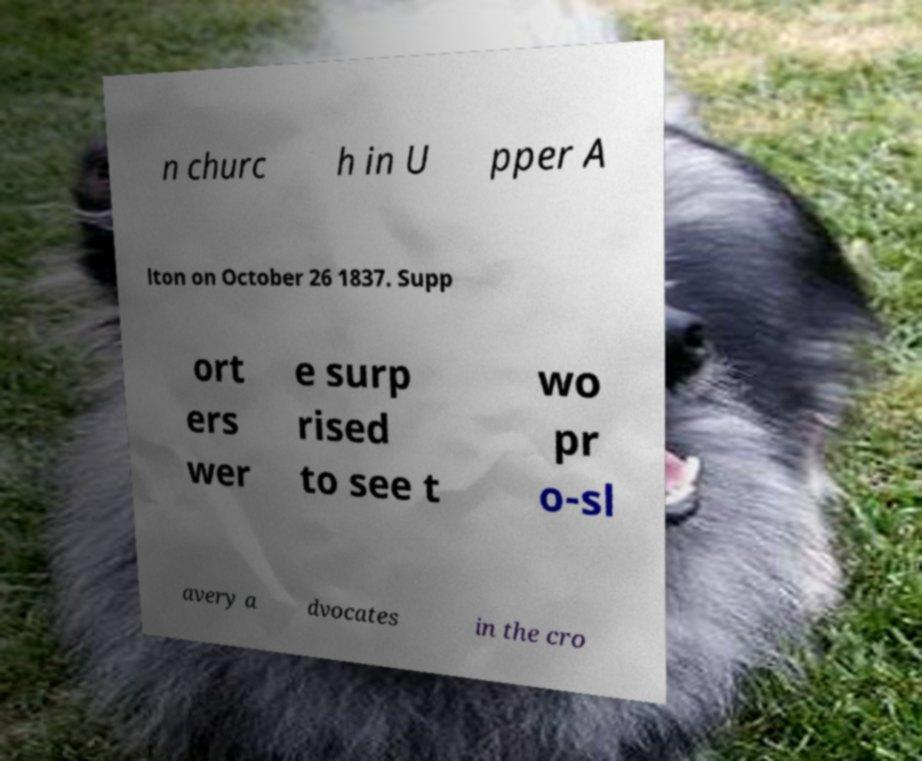For documentation purposes, I need the text within this image transcribed. Could you provide that? n churc h in U pper A lton on October 26 1837. Supp ort ers wer e surp rised to see t wo pr o-sl avery a dvocates in the cro 